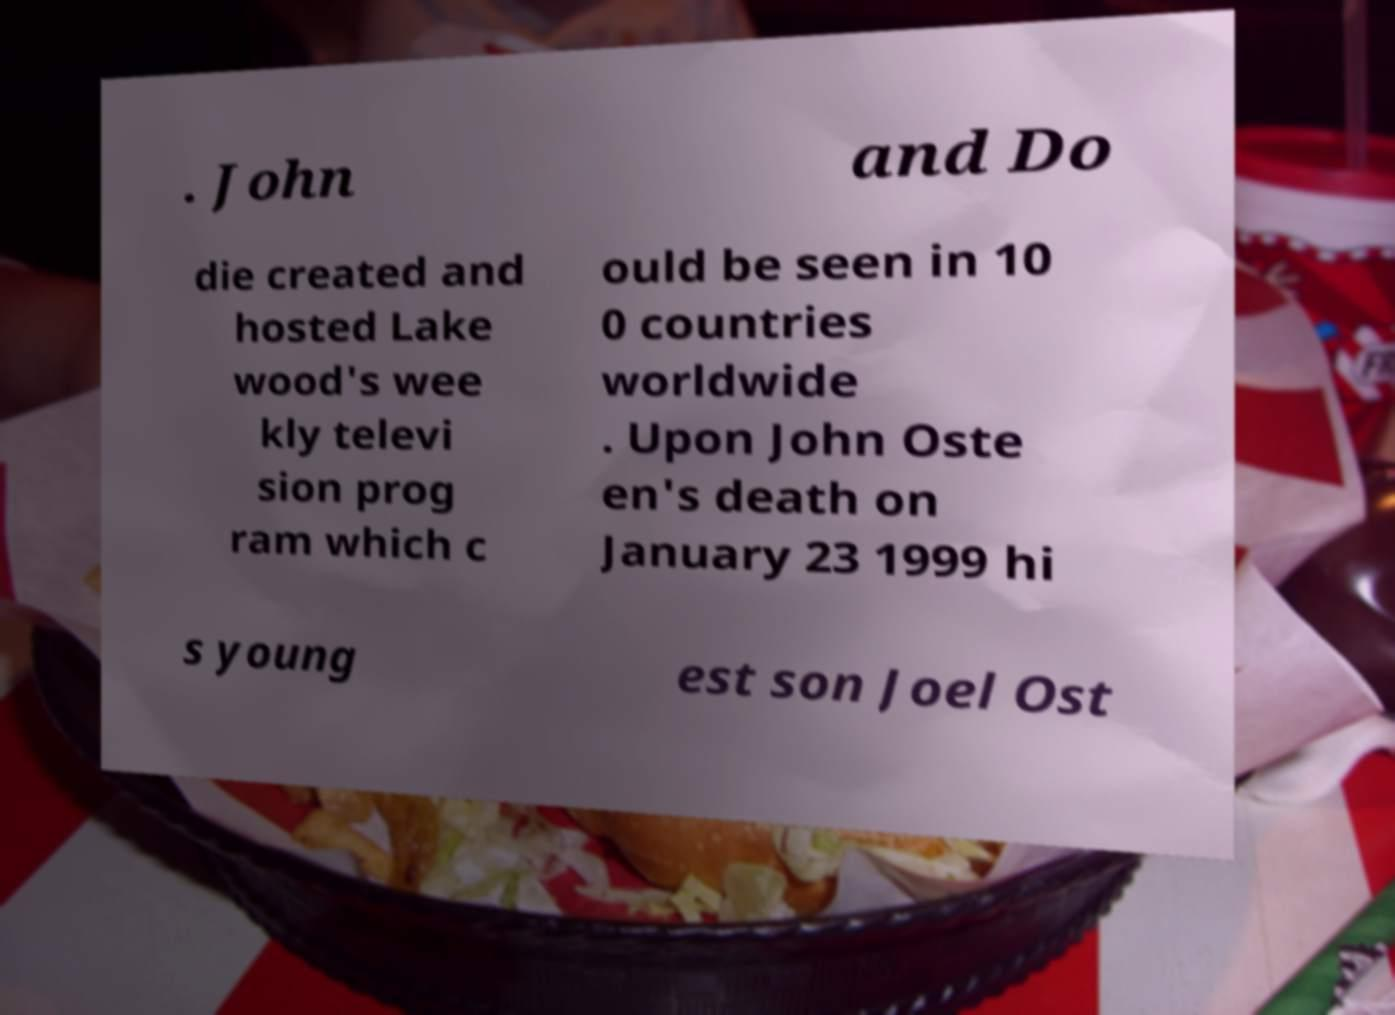Can you read and provide the text displayed in the image?This photo seems to have some interesting text. Can you extract and type it out for me? . John and Do die created and hosted Lake wood's wee kly televi sion prog ram which c ould be seen in 10 0 countries worldwide . Upon John Oste en's death on January 23 1999 hi s young est son Joel Ost 